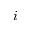Convert formula to latex. <formula><loc_0><loc_0><loc_500><loc_500>i</formula> 